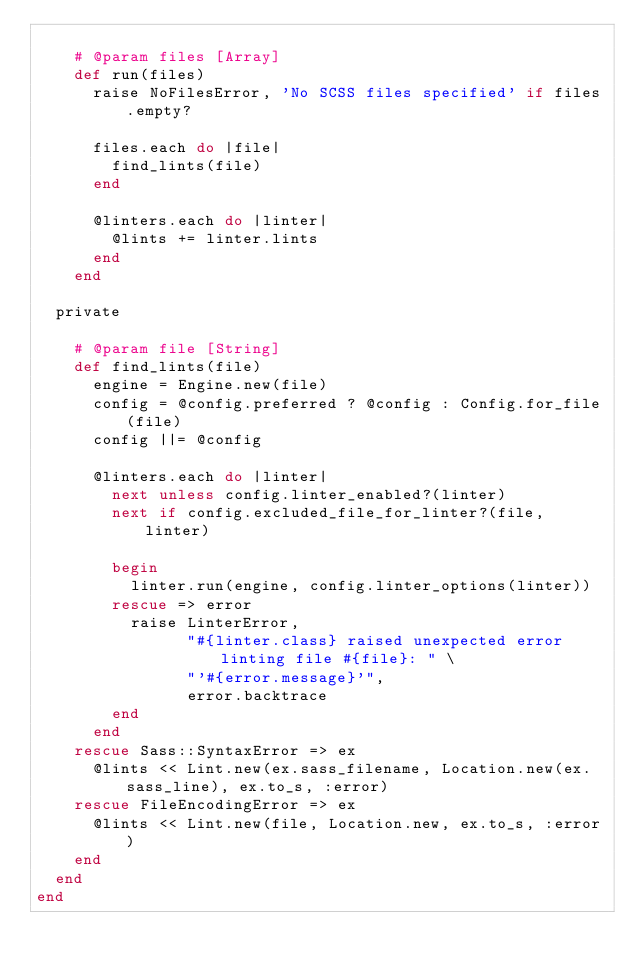<code> <loc_0><loc_0><loc_500><loc_500><_Ruby_>
    # @param files [Array]
    def run(files)
      raise NoFilesError, 'No SCSS files specified' if files.empty?

      files.each do |file|
        find_lints(file)
      end

      @linters.each do |linter|
        @lints += linter.lints
      end
    end

  private

    # @param file [String]
    def find_lints(file)
      engine = Engine.new(file)
      config = @config.preferred ? @config : Config.for_file(file)
      config ||= @config

      @linters.each do |linter|
        next unless config.linter_enabled?(linter)
        next if config.excluded_file_for_linter?(file, linter)

        begin
          linter.run(engine, config.linter_options(linter))
        rescue => error
          raise LinterError,
                "#{linter.class} raised unexpected error linting file #{file}: " \
                "'#{error.message}'",
                error.backtrace
        end
      end
    rescue Sass::SyntaxError => ex
      @lints << Lint.new(ex.sass_filename, Location.new(ex.sass_line), ex.to_s, :error)
    rescue FileEncodingError => ex
      @lints << Lint.new(file, Location.new, ex.to_s, :error)
    end
  end
end
</code> 